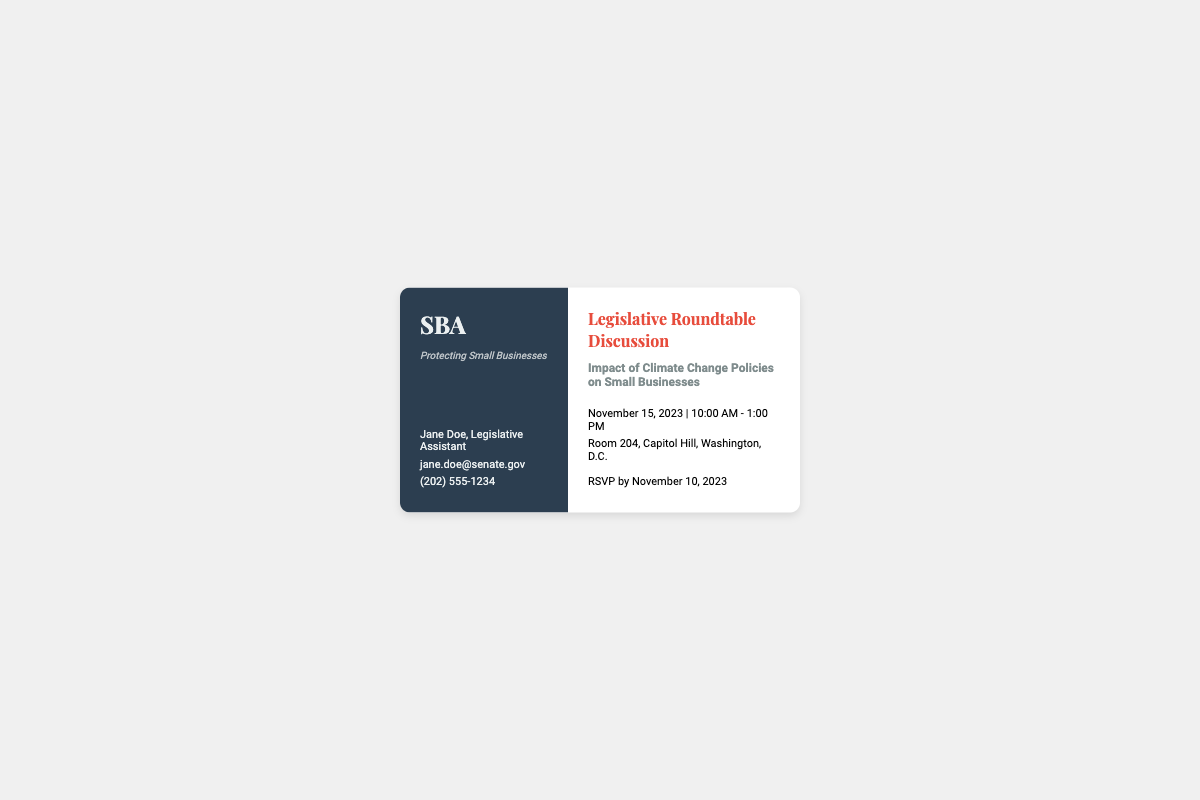What is the event date? The event date is explicitly stated in the document.
Answer: November 15, 2023 Who is the contact person? The document lists a specific individual for contact information.
Answer: Jane Doe What time does the event start? The start time of the event is provided in the details section.
Answer: 10:00 AM What is the room number for the event? The document specifies the location of the event.
Answer: Room 204 When is the RSVP deadline? The RSVP deadline is mentioned in the document.
Answer: November 10, 2023 What is the tagline of the organization? The tagline is included under the logo in the left column.
Answer: Protecting Small Businesses What is the name of the organization? The logo section of the document includes the name of the organization.
Answer: SBA What is the duration of the event? The document mentions the starting and ending time of the event.
Answer: 3 hours 